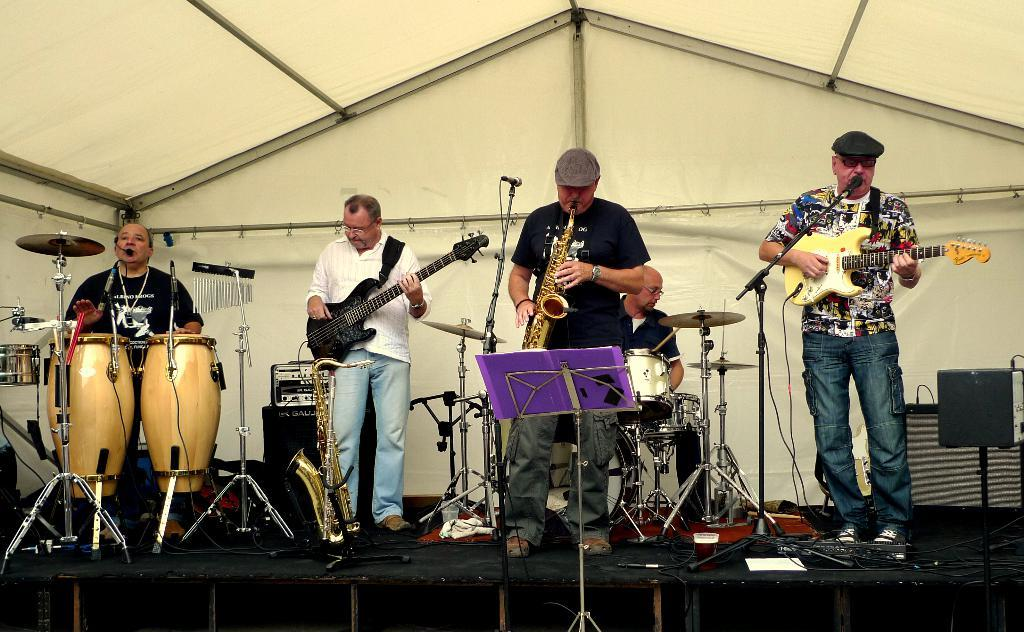What is happening on the stage in the image? There are people on the stage in the image, and they are playing music instruments. What types of music instruments can be seen in the image? There are different types of music instruments being played in the image. What else is present on the stage besides the people and music instruments? There is musical equipment around the people on the stage. What type of stamp can be seen on the committee's document in the image? There is no stamp or committee present in the image; it features people playing music instruments on a stage. 